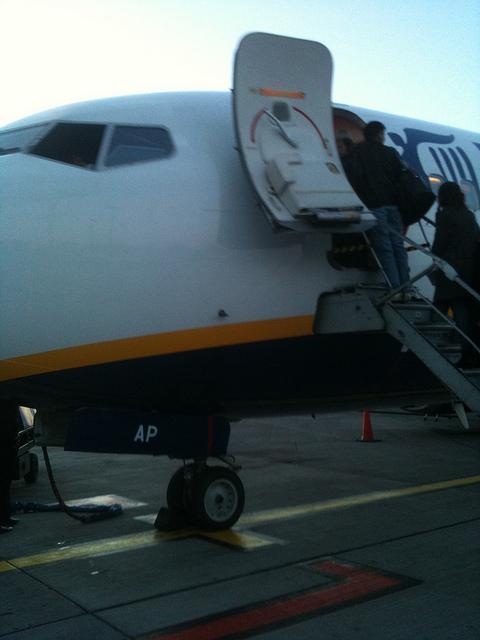What popular news agency as the same Acronym as the letters near the bottom of the plane?
From the following four choices, select the correct answer to address the question.
Options: Associated press, amazing press, awesome people, associated people. Associated press. 